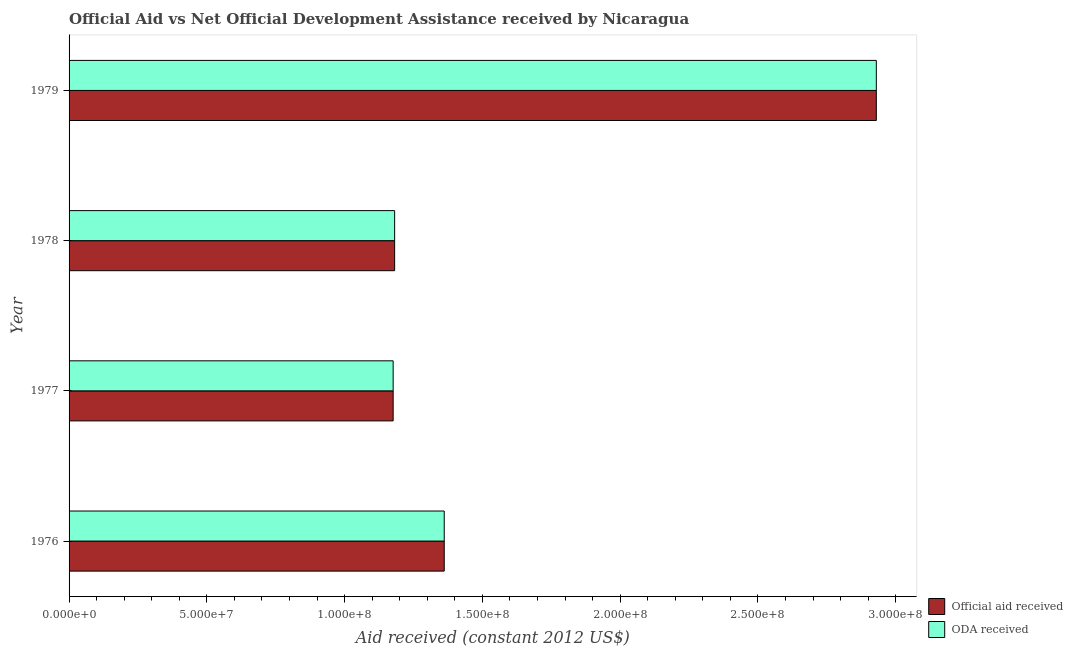How many different coloured bars are there?
Provide a succinct answer. 2. How many groups of bars are there?
Provide a succinct answer. 4. Are the number of bars per tick equal to the number of legend labels?
Keep it short and to the point. Yes. Are the number of bars on each tick of the Y-axis equal?
Your answer should be compact. Yes. How many bars are there on the 3rd tick from the top?
Your response must be concise. 2. What is the label of the 2nd group of bars from the top?
Offer a very short reply. 1978. In how many cases, is the number of bars for a given year not equal to the number of legend labels?
Give a very brief answer. 0. What is the official aid received in 1976?
Your response must be concise. 1.36e+08. Across all years, what is the maximum oda received?
Your answer should be very brief. 2.93e+08. Across all years, what is the minimum official aid received?
Your answer should be compact. 1.18e+08. In which year was the oda received maximum?
Give a very brief answer. 1979. In which year was the oda received minimum?
Make the answer very short. 1977. What is the total official aid received in the graph?
Ensure brevity in your answer.  6.65e+08. What is the difference between the oda received in 1978 and that in 1979?
Your answer should be compact. -1.75e+08. What is the difference between the official aid received in 1979 and the oda received in 1977?
Your answer should be very brief. 1.75e+08. What is the average oda received per year?
Ensure brevity in your answer.  1.66e+08. In the year 1976, what is the difference between the oda received and official aid received?
Ensure brevity in your answer.  0. In how many years, is the official aid received greater than 70000000 US$?
Ensure brevity in your answer.  4. What is the ratio of the oda received in 1976 to that in 1979?
Provide a short and direct response. 0.47. Is the oda received in 1976 less than that in 1979?
Your answer should be very brief. Yes. Is the difference between the official aid received in 1978 and 1979 greater than the difference between the oda received in 1978 and 1979?
Ensure brevity in your answer.  No. What is the difference between the highest and the second highest oda received?
Offer a very short reply. 1.57e+08. What is the difference between the highest and the lowest official aid received?
Keep it short and to the point. 1.75e+08. In how many years, is the official aid received greater than the average official aid received taken over all years?
Your response must be concise. 1. Is the sum of the official aid received in 1977 and 1979 greater than the maximum oda received across all years?
Your answer should be very brief. Yes. What does the 1st bar from the top in 1979 represents?
Make the answer very short. ODA received. What does the 1st bar from the bottom in 1978 represents?
Give a very brief answer. Official aid received. Are all the bars in the graph horizontal?
Offer a terse response. Yes. How many years are there in the graph?
Your answer should be very brief. 4. Are the values on the major ticks of X-axis written in scientific E-notation?
Give a very brief answer. Yes. How are the legend labels stacked?
Your answer should be very brief. Vertical. What is the title of the graph?
Provide a short and direct response. Official Aid vs Net Official Development Assistance received by Nicaragua . What is the label or title of the X-axis?
Give a very brief answer. Aid received (constant 2012 US$). What is the label or title of the Y-axis?
Offer a terse response. Year. What is the Aid received (constant 2012 US$) of Official aid received in 1976?
Your response must be concise. 1.36e+08. What is the Aid received (constant 2012 US$) in ODA received in 1976?
Provide a short and direct response. 1.36e+08. What is the Aid received (constant 2012 US$) of Official aid received in 1977?
Provide a succinct answer. 1.18e+08. What is the Aid received (constant 2012 US$) in ODA received in 1977?
Your answer should be very brief. 1.18e+08. What is the Aid received (constant 2012 US$) in Official aid received in 1978?
Make the answer very short. 1.18e+08. What is the Aid received (constant 2012 US$) of ODA received in 1978?
Your response must be concise. 1.18e+08. What is the Aid received (constant 2012 US$) of Official aid received in 1979?
Make the answer very short. 2.93e+08. What is the Aid received (constant 2012 US$) in ODA received in 1979?
Offer a terse response. 2.93e+08. Across all years, what is the maximum Aid received (constant 2012 US$) of Official aid received?
Your answer should be compact. 2.93e+08. Across all years, what is the maximum Aid received (constant 2012 US$) of ODA received?
Offer a terse response. 2.93e+08. Across all years, what is the minimum Aid received (constant 2012 US$) in Official aid received?
Ensure brevity in your answer.  1.18e+08. Across all years, what is the minimum Aid received (constant 2012 US$) of ODA received?
Your answer should be compact. 1.18e+08. What is the total Aid received (constant 2012 US$) in Official aid received in the graph?
Ensure brevity in your answer.  6.65e+08. What is the total Aid received (constant 2012 US$) of ODA received in the graph?
Your answer should be very brief. 6.65e+08. What is the difference between the Aid received (constant 2012 US$) of Official aid received in 1976 and that in 1977?
Keep it short and to the point. 1.85e+07. What is the difference between the Aid received (constant 2012 US$) in ODA received in 1976 and that in 1977?
Make the answer very short. 1.85e+07. What is the difference between the Aid received (constant 2012 US$) of Official aid received in 1976 and that in 1978?
Give a very brief answer. 1.80e+07. What is the difference between the Aid received (constant 2012 US$) in ODA received in 1976 and that in 1978?
Keep it short and to the point. 1.80e+07. What is the difference between the Aid received (constant 2012 US$) in Official aid received in 1976 and that in 1979?
Ensure brevity in your answer.  -1.57e+08. What is the difference between the Aid received (constant 2012 US$) in ODA received in 1976 and that in 1979?
Offer a terse response. -1.57e+08. What is the difference between the Aid received (constant 2012 US$) in Official aid received in 1977 and that in 1978?
Offer a very short reply. -5.40e+05. What is the difference between the Aid received (constant 2012 US$) of ODA received in 1977 and that in 1978?
Provide a succinct answer. -5.40e+05. What is the difference between the Aid received (constant 2012 US$) of Official aid received in 1977 and that in 1979?
Ensure brevity in your answer.  -1.75e+08. What is the difference between the Aid received (constant 2012 US$) in ODA received in 1977 and that in 1979?
Your response must be concise. -1.75e+08. What is the difference between the Aid received (constant 2012 US$) of Official aid received in 1978 and that in 1979?
Give a very brief answer. -1.75e+08. What is the difference between the Aid received (constant 2012 US$) in ODA received in 1978 and that in 1979?
Offer a very short reply. -1.75e+08. What is the difference between the Aid received (constant 2012 US$) in Official aid received in 1976 and the Aid received (constant 2012 US$) in ODA received in 1977?
Make the answer very short. 1.85e+07. What is the difference between the Aid received (constant 2012 US$) in Official aid received in 1976 and the Aid received (constant 2012 US$) in ODA received in 1978?
Provide a succinct answer. 1.80e+07. What is the difference between the Aid received (constant 2012 US$) of Official aid received in 1976 and the Aid received (constant 2012 US$) of ODA received in 1979?
Offer a terse response. -1.57e+08. What is the difference between the Aid received (constant 2012 US$) in Official aid received in 1977 and the Aid received (constant 2012 US$) in ODA received in 1978?
Your answer should be very brief. -5.40e+05. What is the difference between the Aid received (constant 2012 US$) of Official aid received in 1977 and the Aid received (constant 2012 US$) of ODA received in 1979?
Offer a very short reply. -1.75e+08. What is the difference between the Aid received (constant 2012 US$) in Official aid received in 1978 and the Aid received (constant 2012 US$) in ODA received in 1979?
Provide a succinct answer. -1.75e+08. What is the average Aid received (constant 2012 US$) in Official aid received per year?
Your response must be concise. 1.66e+08. What is the average Aid received (constant 2012 US$) in ODA received per year?
Give a very brief answer. 1.66e+08. In the year 1976, what is the difference between the Aid received (constant 2012 US$) in Official aid received and Aid received (constant 2012 US$) in ODA received?
Your answer should be compact. 0. In the year 1977, what is the difference between the Aid received (constant 2012 US$) of Official aid received and Aid received (constant 2012 US$) of ODA received?
Your response must be concise. 0. In the year 1979, what is the difference between the Aid received (constant 2012 US$) of Official aid received and Aid received (constant 2012 US$) of ODA received?
Keep it short and to the point. 0. What is the ratio of the Aid received (constant 2012 US$) of Official aid received in 1976 to that in 1977?
Your answer should be compact. 1.16. What is the ratio of the Aid received (constant 2012 US$) of ODA received in 1976 to that in 1977?
Your answer should be very brief. 1.16. What is the ratio of the Aid received (constant 2012 US$) of Official aid received in 1976 to that in 1978?
Your response must be concise. 1.15. What is the ratio of the Aid received (constant 2012 US$) of ODA received in 1976 to that in 1978?
Give a very brief answer. 1.15. What is the ratio of the Aid received (constant 2012 US$) in Official aid received in 1976 to that in 1979?
Your answer should be compact. 0.46. What is the ratio of the Aid received (constant 2012 US$) of ODA received in 1976 to that in 1979?
Your answer should be very brief. 0.46. What is the ratio of the Aid received (constant 2012 US$) of ODA received in 1977 to that in 1978?
Provide a succinct answer. 1. What is the ratio of the Aid received (constant 2012 US$) of Official aid received in 1977 to that in 1979?
Provide a succinct answer. 0.4. What is the ratio of the Aid received (constant 2012 US$) in ODA received in 1977 to that in 1979?
Your answer should be compact. 0.4. What is the ratio of the Aid received (constant 2012 US$) of Official aid received in 1978 to that in 1979?
Ensure brevity in your answer.  0.4. What is the ratio of the Aid received (constant 2012 US$) in ODA received in 1978 to that in 1979?
Offer a terse response. 0.4. What is the difference between the highest and the second highest Aid received (constant 2012 US$) in Official aid received?
Offer a terse response. 1.57e+08. What is the difference between the highest and the second highest Aid received (constant 2012 US$) of ODA received?
Your response must be concise. 1.57e+08. What is the difference between the highest and the lowest Aid received (constant 2012 US$) of Official aid received?
Keep it short and to the point. 1.75e+08. What is the difference between the highest and the lowest Aid received (constant 2012 US$) in ODA received?
Make the answer very short. 1.75e+08. 